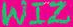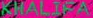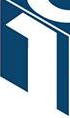What text is displayed in these images sequentially, separated by a semicolon? WIZ; KHALIFA; 1 